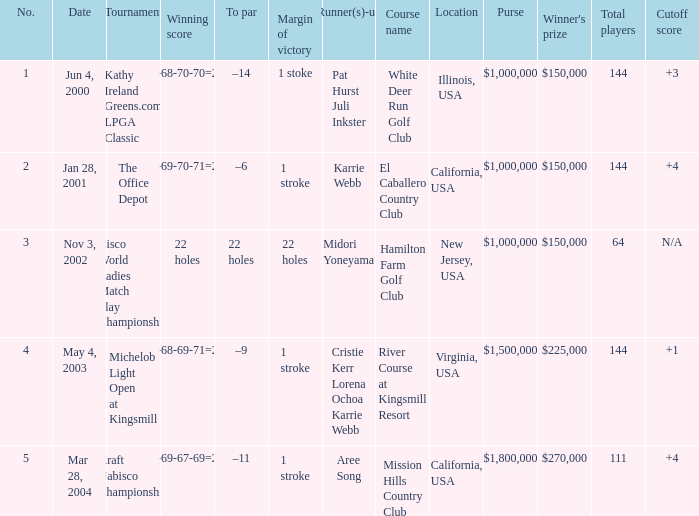I'm looking to parse the entire table for insights. Could you assist me with that? {'header': ['No.', 'Date', 'Tournament', 'Winning score', 'To par', 'Margin of victory', 'Runner(s)-up', 'Course name', 'Location', 'Purse', "Winner's prize", 'Total players', 'Cutoff score'], 'rows': [['1', 'Jun 4, 2000', 'Kathy Ireland Greens.com LPGA Classic', '66-68-70-70=274', '–14', '1 stoke', 'Pat Hurst Juli Inkster', 'White Deer Run Golf Club', 'Illinois, USA', '$1,000,000', '$150,000', '144', '+3'], ['2', 'Jan 28, 2001', 'The Office Depot', '70-69-70-71=280', '–6', '1 stroke', 'Karrie Webb', 'El Caballero Country Club', 'California, USA', '$1,000,000', '$150,000', '144', '+4'], ['3', 'Nov 3, 2002', 'Cisco World Ladies Match Play Championship', '22 holes', '22 holes', '22 holes', 'Midori Yoneyama', 'Hamilton Farm Golf Club', 'New Jersey, USA', '$1,000,000', '$150,000', '64', 'N/A'], ['4', 'May 4, 2003', 'Michelob Light Open at Kingsmill', '67-68-69-71=275', '–9', '1 stroke', 'Cristie Kerr Lorena Ochoa Karrie Webb', 'River Course at Kingsmill Resort', 'Virginia, USA', '$1,500,000', '$225,000', '144', '+1'], ['5', 'Mar 28, 2004', 'Kraft Nabisco Championship', '72-69-67-69=277', '–11', '1 stroke', 'Aree Song', 'Mission Hills Country Club', 'California, USA', '$1,800,000', '$270,000', '111', '+4']]} What date were the runner ups pat hurst juli inkster? Jun 4, 2000. 